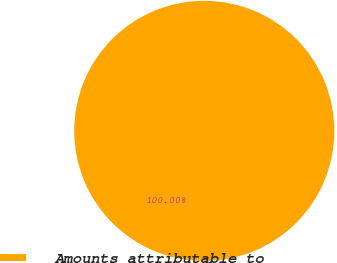<chart> <loc_0><loc_0><loc_500><loc_500><pie_chart><fcel>Amounts attributable to<nl><fcel>100.0%<nl></chart> 